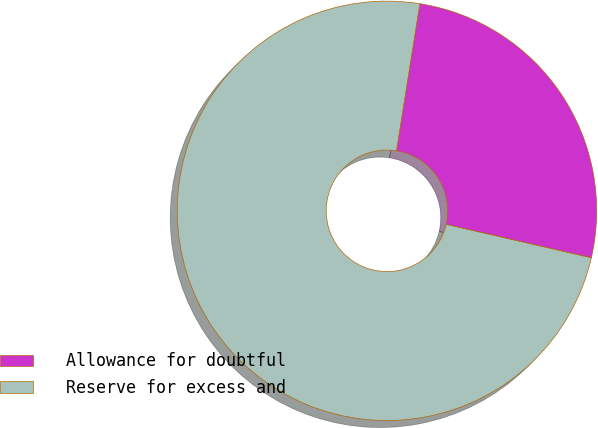Convert chart. <chart><loc_0><loc_0><loc_500><loc_500><pie_chart><fcel>Allowance for doubtful<fcel>Reserve for excess and<nl><fcel>26.09%<fcel>73.91%<nl></chart> 